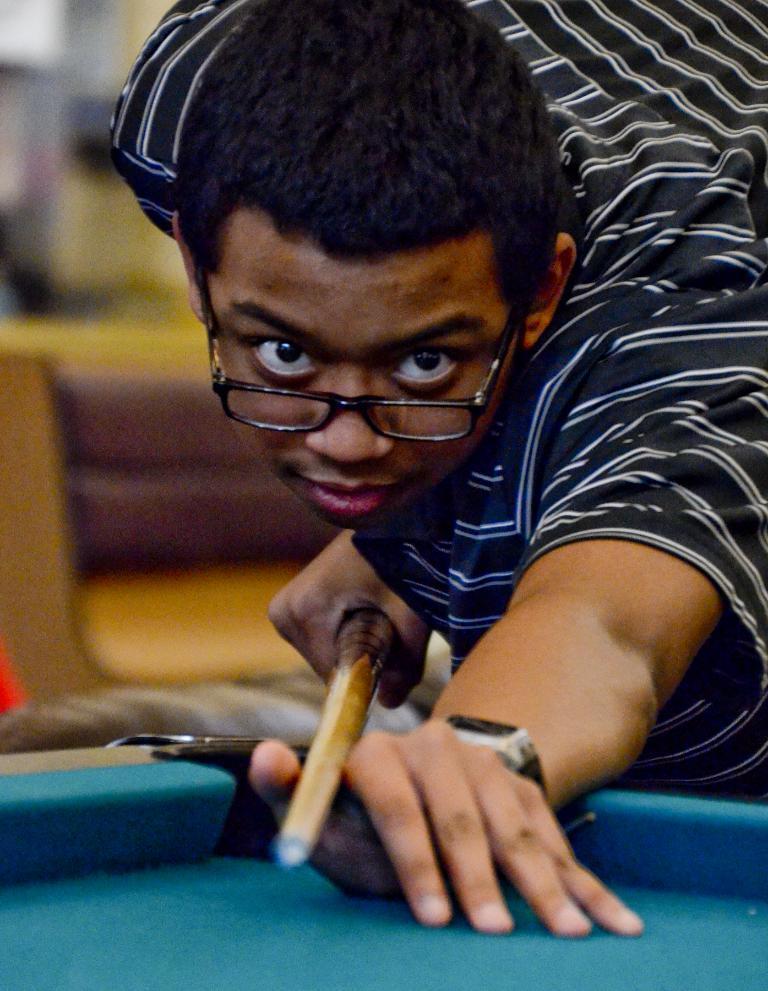Describe this image in one or two sentences. A man is playing snooker game. 